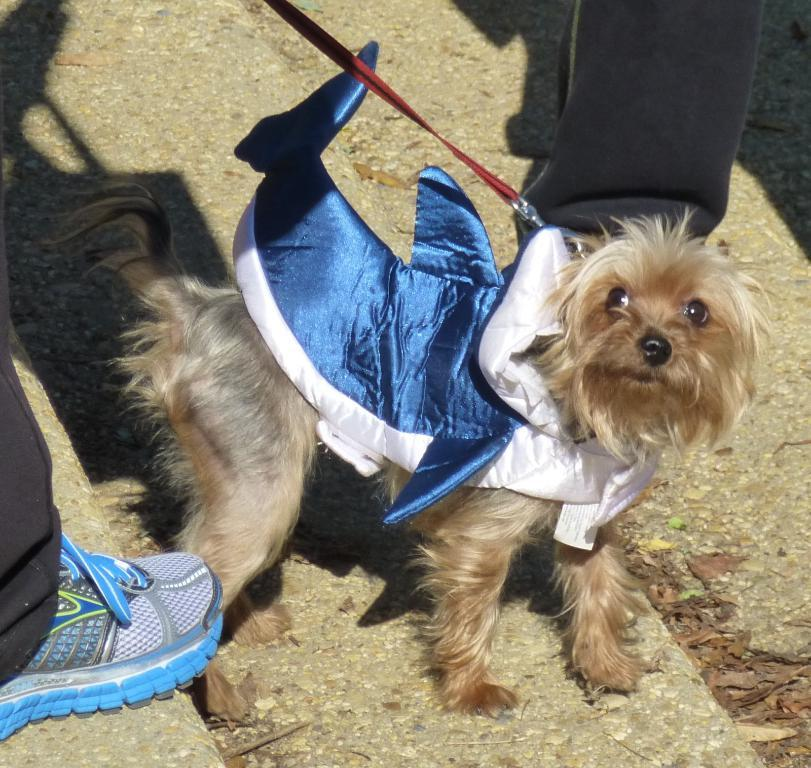What type of animal is in the image? There is a dog in the image. What color is the dog? The dog is brown in color. How is the dog dressed or wrapped in the image? The dog is wrapped in a cloth that is white and blue. What color is the leash attached to the dog? The dog has a red leash. Can you see any human body parts in the image? Yes, there are legs of people visible in the image. How many trucks are parked next to the dog in the image? There are no trucks present in the image; it features a dog wrapped in a cloth with a red leash and people's legs visible. 